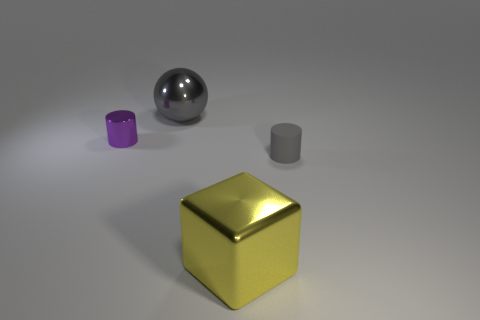What is the color of the tiny object that is made of the same material as the block?
Your answer should be very brief. Purple. Is the number of cylinders on the right side of the tiny rubber cylinder less than the number of gray cylinders?
Ensure brevity in your answer.  Yes. There is a yellow thing that is the same material as the gray sphere; what is its shape?
Your response must be concise. Cube. What number of metal things are either large balls or purple objects?
Provide a succinct answer. 2. Are there an equal number of yellow metal objects left of the large gray thing and purple metallic cylinders?
Give a very brief answer. No. Does the block that is right of the large gray ball have the same color as the big sphere?
Your answer should be compact. No. What is the object that is both in front of the big gray metallic ball and behind the small gray cylinder made of?
Keep it short and to the point. Metal. Are there any small purple cylinders that are on the right side of the big cube in front of the purple cylinder?
Ensure brevity in your answer.  No. Do the small gray cylinder and the large gray ball have the same material?
Give a very brief answer. No. There is a shiny object that is on the left side of the yellow metallic cube and in front of the big ball; what shape is it?
Ensure brevity in your answer.  Cylinder. 